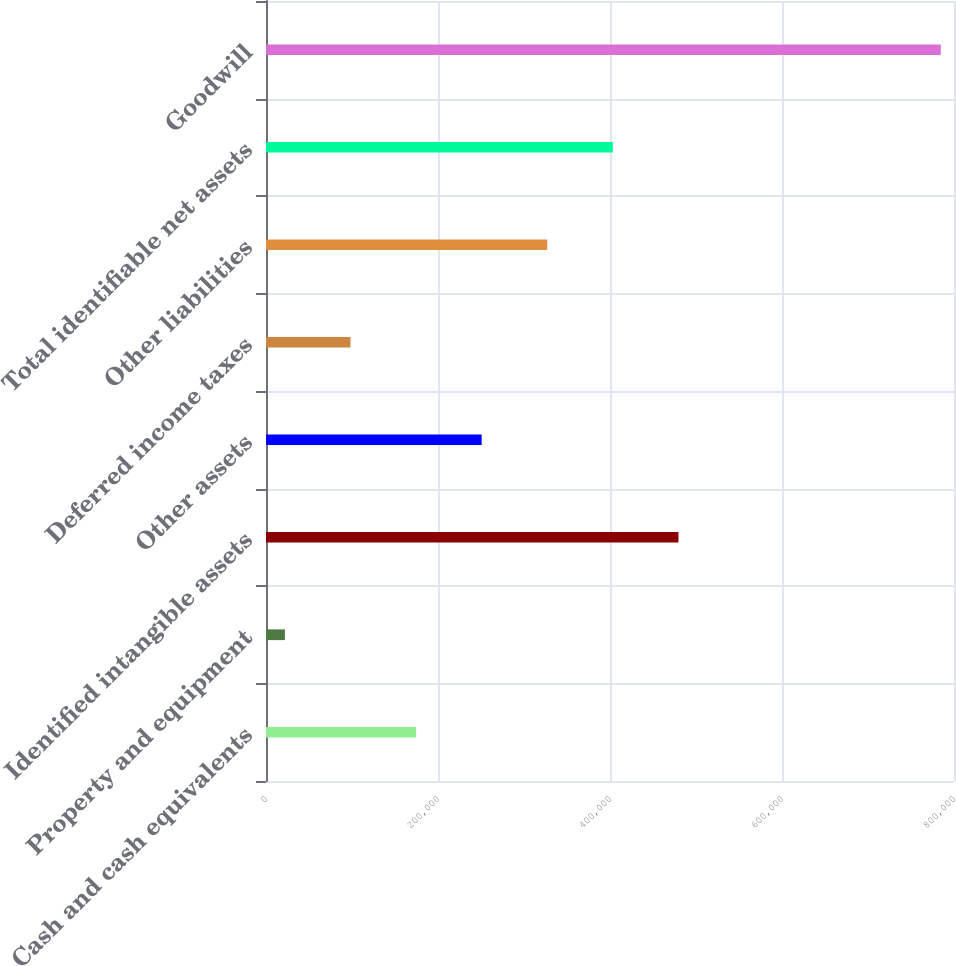Convert chart. <chart><loc_0><loc_0><loc_500><loc_500><bar_chart><fcel>Cash and cash equivalents<fcel>Property and equipment<fcel>Identified intangible assets<fcel>Other assets<fcel>Deferred income taxes<fcel>Other liabilities<fcel>Total identifiable net assets<fcel>Goodwill<nl><fcel>174522<fcel>21985<fcel>479595<fcel>250790<fcel>98253.3<fcel>327058<fcel>403326<fcel>784668<nl></chart> 